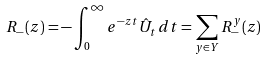<formula> <loc_0><loc_0><loc_500><loc_500>R _ { - } ( z ) = - \int _ { 0 } ^ { \infty } e ^ { - z t } \hat { U } _ { t } \, d t = \sum _ { y \in Y } R _ { - } ^ { y } ( z )</formula> 